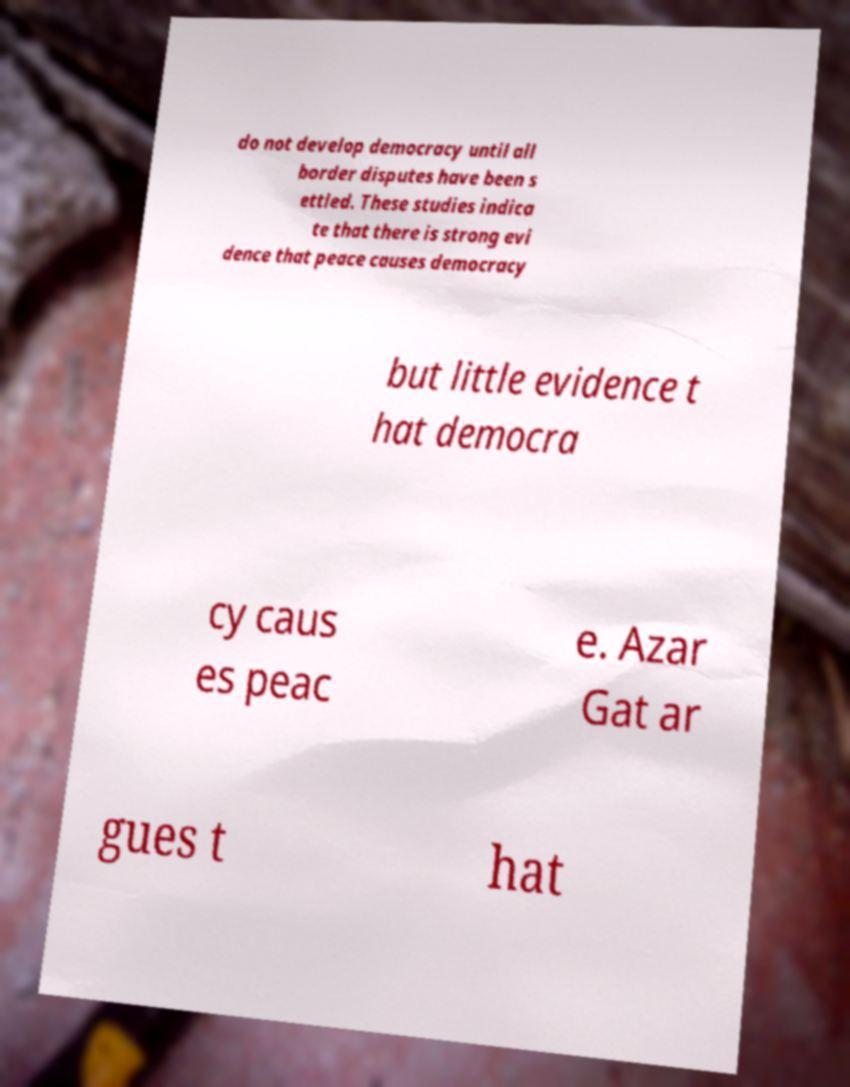Could you extract and type out the text from this image? do not develop democracy until all border disputes have been s ettled. These studies indica te that there is strong evi dence that peace causes democracy but little evidence t hat democra cy caus es peac e. Azar Gat ar gues t hat 